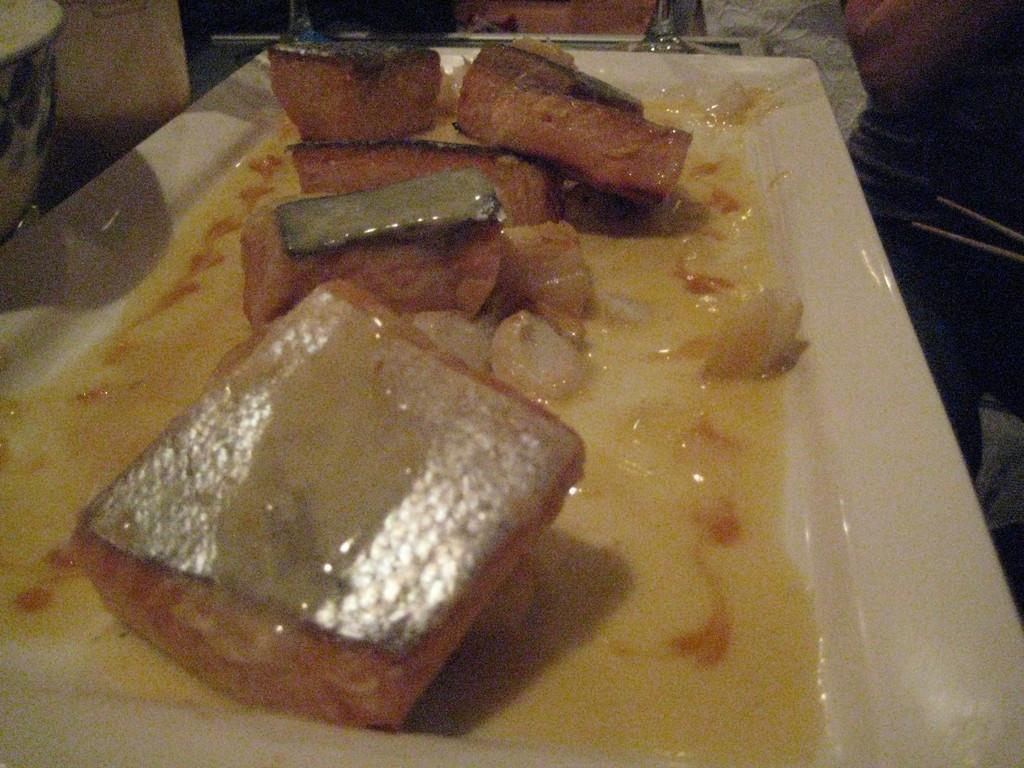What types of food items can be seen in the image? There are food items in the image, including soup in a plate. Can you describe the soup in the plate? The soup is in a plate in the image. What else can be seen in the background of the image? There are objects visible in the background of the image. What type of pencil can be seen in the image? There is no pencil present in the image. Is there any ice visible in the image? There is no ice visible in the image. 